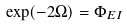Convert formula to latex. <formula><loc_0><loc_0><loc_500><loc_500>\exp ( - 2 \Omega ) = \Phi _ { E I }</formula> 